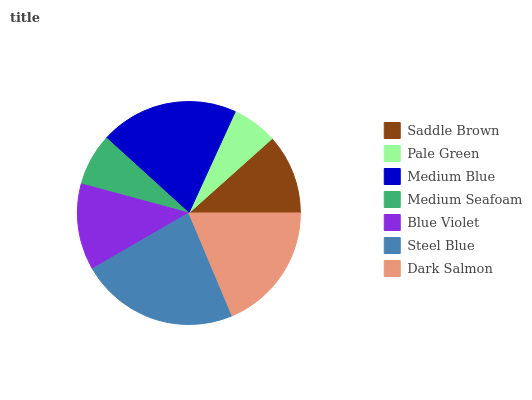Is Pale Green the minimum?
Answer yes or no. Yes. Is Steel Blue the maximum?
Answer yes or no. Yes. Is Medium Blue the minimum?
Answer yes or no. No. Is Medium Blue the maximum?
Answer yes or no. No. Is Medium Blue greater than Pale Green?
Answer yes or no. Yes. Is Pale Green less than Medium Blue?
Answer yes or no. Yes. Is Pale Green greater than Medium Blue?
Answer yes or no. No. Is Medium Blue less than Pale Green?
Answer yes or no. No. Is Blue Violet the high median?
Answer yes or no. Yes. Is Blue Violet the low median?
Answer yes or no. Yes. Is Medium Seafoam the high median?
Answer yes or no. No. Is Pale Green the low median?
Answer yes or no. No. 